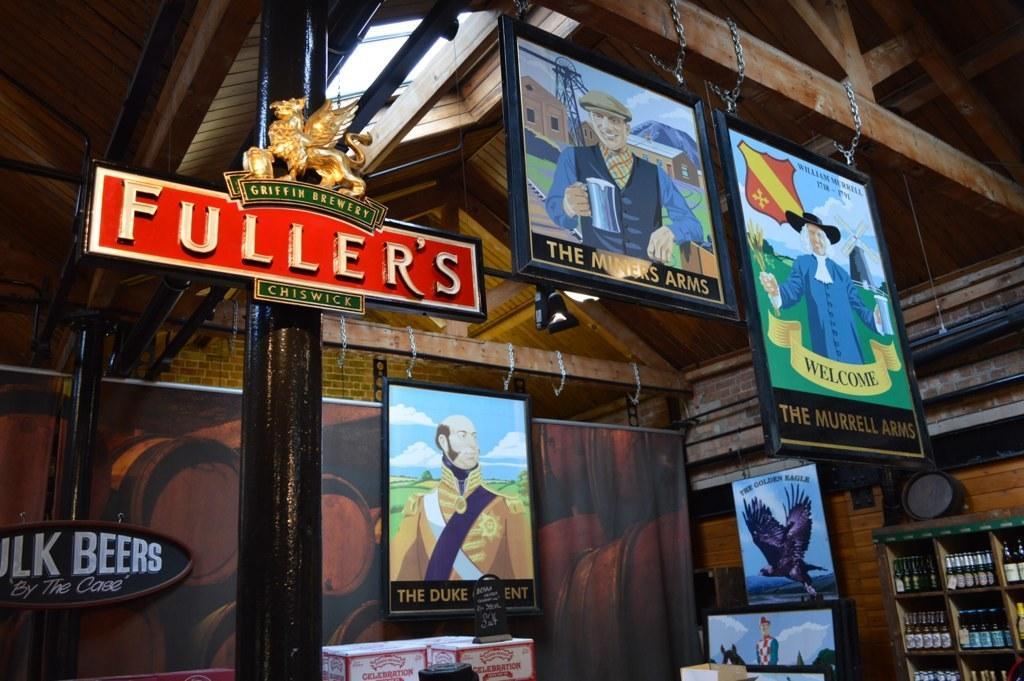Can you describe this image briefly? In this image there is a wooden roof, there are photo frameś hanged from the roof, there are bottles on the shelves towards the right of the image, there is a photo frame towards the right of the image, there are lightś, there is a board with red color and text written on it, towards the left of the image there is a board attached to the pillar with text written on it. 